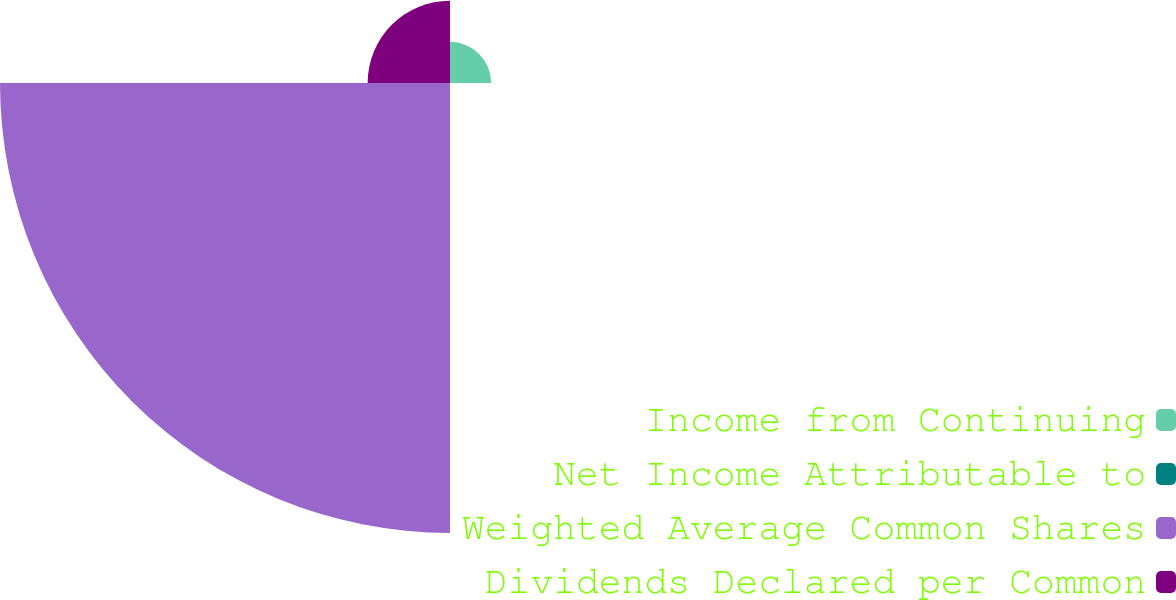Convert chart. <chart><loc_0><loc_0><loc_500><loc_500><pie_chart><fcel>Income from Continuing<fcel>Net Income Attributable to<fcel>Weighted Average Common Shares<fcel>Dividends Declared per Common<nl><fcel>7.18%<fcel>0.0%<fcel>78.46%<fcel>14.36%<nl></chart> 